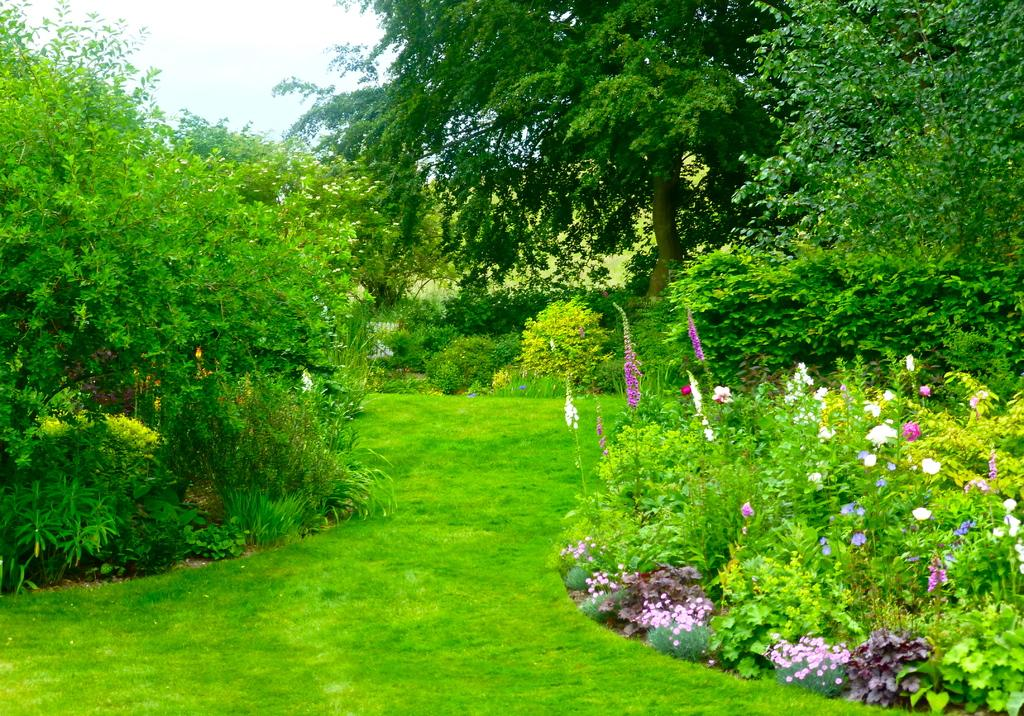What types of vegetation can be seen on the right side of the image? There are plants, flowers, and trees on the right side of the image. What types of vegetation can be seen on the left side of the image? There are plants, flowers, and trees on the left side of the image. What is present at the bottom of the image? There is grass at the bottom of the image. What can be seen in the background of the image? There are trees and the sky visible in the background of the image. Can you describe the hen sitting on the windowsill in the image? There is no hen or windowsill present in the image. 